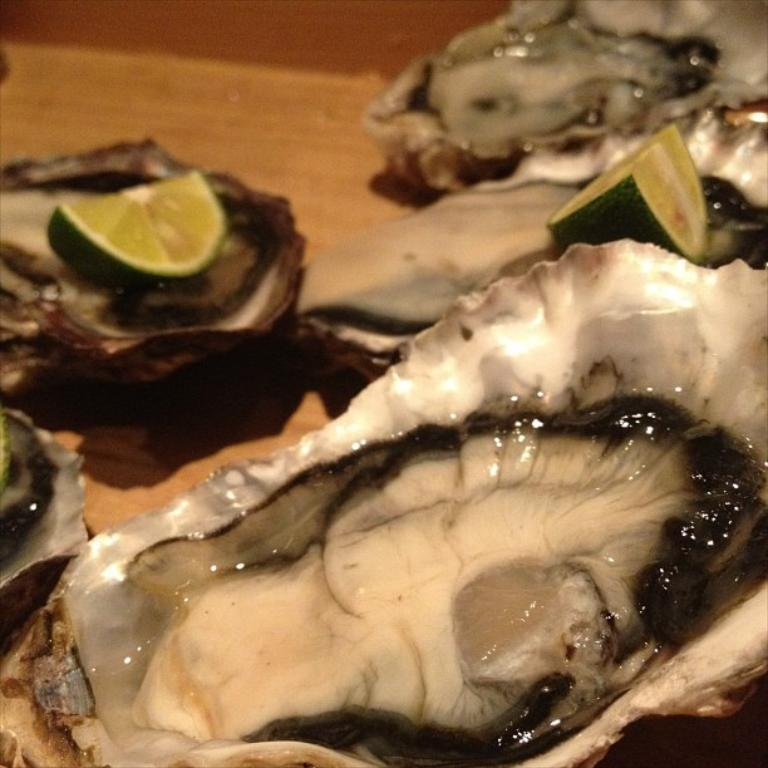What type of seafood is present in the image? There are oysters in the image. What accompanies the oysters in the image? There are lemon slices in the image. On what object are the oysters and lemon slices placed? The oysters and lemon slices are on an object. How many hens are resting on the beds in the image? There are no hens or beds present in the image. What type of wind can be seen blowing through the zephyr in the image? There is no zephyr or wind present in the image. 